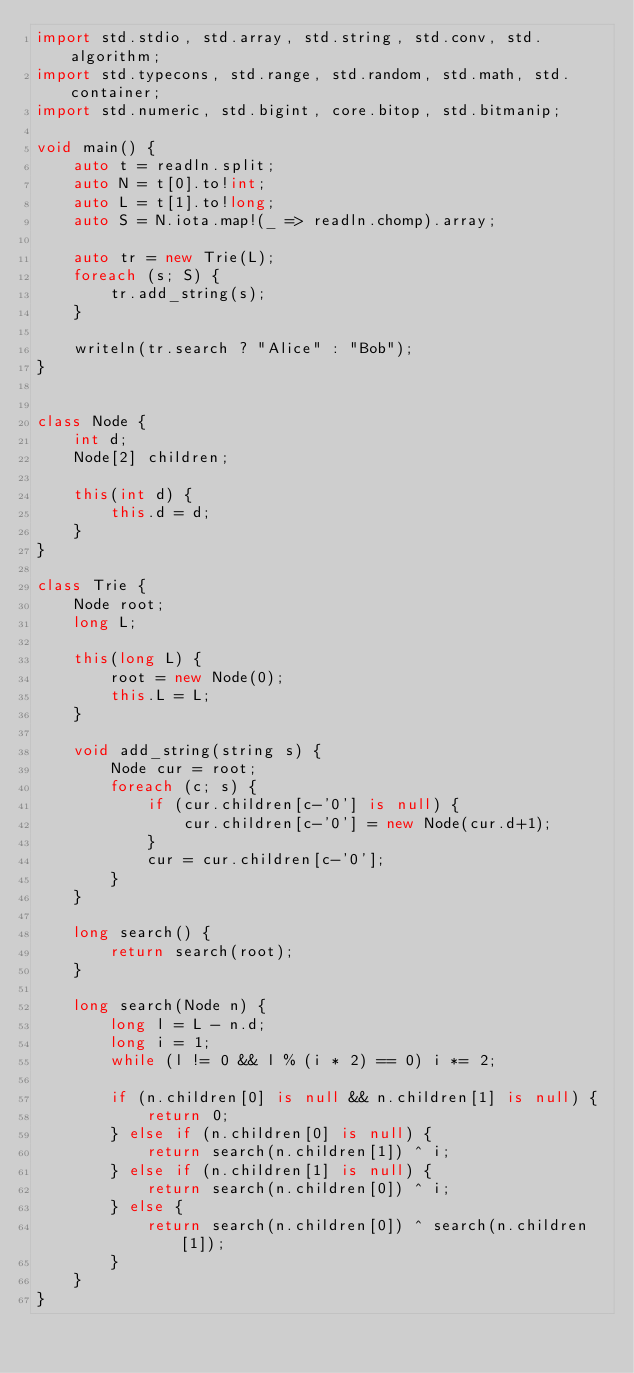<code> <loc_0><loc_0><loc_500><loc_500><_D_>import std.stdio, std.array, std.string, std.conv, std.algorithm;
import std.typecons, std.range, std.random, std.math, std.container;
import std.numeric, std.bigint, core.bitop, std.bitmanip;

void main() {
    auto t = readln.split;
    auto N = t[0].to!int;
    auto L = t[1].to!long;
    auto S = N.iota.map!(_ => readln.chomp).array;

    auto tr = new Trie(L);
    foreach (s; S) {
        tr.add_string(s);
    }

    writeln(tr.search ? "Alice" : "Bob");
}


class Node {
    int d;
    Node[2] children;

    this(int d) {
        this.d = d;
    }
}

class Trie {
    Node root;
    long L;

    this(long L) {
        root = new Node(0);
        this.L = L;
    }

    void add_string(string s) {
        Node cur = root;
        foreach (c; s) {
            if (cur.children[c-'0'] is null) {
                cur.children[c-'0'] = new Node(cur.d+1);
            }
            cur = cur.children[c-'0'];
        }
    }

    long search() {
        return search(root);
    }
    
    long search(Node n) {
        long l = L - n.d;
        long i = 1;
        while (l != 0 && l % (i * 2) == 0) i *= 2;
        
        if (n.children[0] is null && n.children[1] is null) {
            return 0;
        } else if (n.children[0] is null) {
            return search(n.children[1]) ^ i;
        } else if (n.children[1] is null) {
            return search(n.children[0]) ^ i;            
        } else {
            return search(n.children[0]) ^ search(n.children[1]);            
        }
    }
}
</code> 